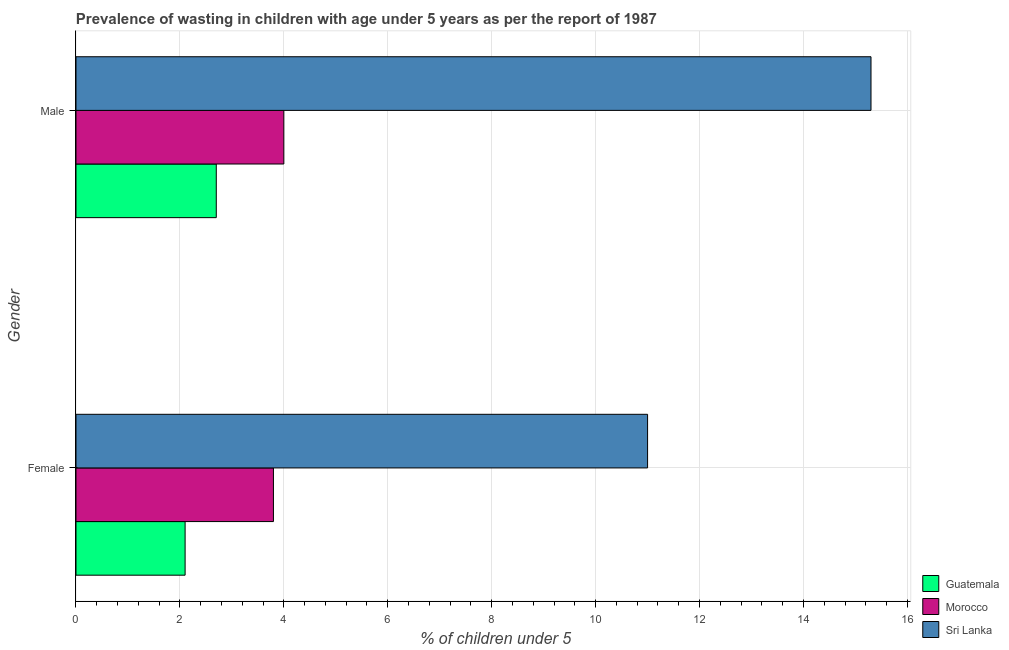How many different coloured bars are there?
Your answer should be compact. 3. What is the label of the 2nd group of bars from the top?
Offer a very short reply. Female. What is the percentage of undernourished female children in Morocco?
Your answer should be very brief. 3.8. Across all countries, what is the maximum percentage of undernourished female children?
Make the answer very short. 11. Across all countries, what is the minimum percentage of undernourished female children?
Offer a very short reply. 2.1. In which country was the percentage of undernourished male children maximum?
Make the answer very short. Sri Lanka. In which country was the percentage of undernourished male children minimum?
Offer a very short reply. Guatemala. What is the total percentage of undernourished female children in the graph?
Offer a very short reply. 16.9. What is the difference between the percentage of undernourished female children in Morocco and that in Guatemala?
Provide a succinct answer. 1.7. What is the difference between the percentage of undernourished male children in Sri Lanka and the percentage of undernourished female children in Morocco?
Your answer should be compact. 11.5. What is the average percentage of undernourished male children per country?
Make the answer very short. 7.33. What is the difference between the percentage of undernourished male children and percentage of undernourished female children in Sri Lanka?
Offer a very short reply. 4.3. What is the ratio of the percentage of undernourished male children in Morocco to that in Sri Lanka?
Provide a short and direct response. 0.26. What does the 1st bar from the top in Female represents?
Make the answer very short. Sri Lanka. What does the 3rd bar from the bottom in Male represents?
Offer a very short reply. Sri Lanka. Are all the bars in the graph horizontal?
Your answer should be compact. Yes. How many countries are there in the graph?
Provide a short and direct response. 3. Does the graph contain any zero values?
Your response must be concise. No. Does the graph contain grids?
Provide a short and direct response. Yes. Where does the legend appear in the graph?
Provide a short and direct response. Bottom right. How are the legend labels stacked?
Make the answer very short. Vertical. What is the title of the graph?
Provide a succinct answer. Prevalence of wasting in children with age under 5 years as per the report of 1987. Does "Australia" appear as one of the legend labels in the graph?
Your answer should be compact. No. What is the label or title of the X-axis?
Provide a succinct answer.  % of children under 5. What is the  % of children under 5 of Guatemala in Female?
Keep it short and to the point. 2.1. What is the  % of children under 5 in Morocco in Female?
Provide a succinct answer. 3.8. What is the  % of children under 5 in Sri Lanka in Female?
Keep it short and to the point. 11. What is the  % of children under 5 in Guatemala in Male?
Provide a succinct answer. 2.7. What is the  % of children under 5 of Sri Lanka in Male?
Your response must be concise. 15.3. Across all Gender, what is the maximum  % of children under 5 of Guatemala?
Ensure brevity in your answer.  2.7. Across all Gender, what is the maximum  % of children under 5 in Morocco?
Your answer should be compact. 4. Across all Gender, what is the maximum  % of children under 5 in Sri Lanka?
Provide a succinct answer. 15.3. Across all Gender, what is the minimum  % of children under 5 in Guatemala?
Your answer should be very brief. 2.1. Across all Gender, what is the minimum  % of children under 5 of Morocco?
Keep it short and to the point. 3.8. What is the total  % of children under 5 of Sri Lanka in the graph?
Provide a succinct answer. 26.3. What is the difference between the  % of children under 5 of Guatemala in Female and that in Male?
Offer a very short reply. -0.6. What is the difference between the  % of children under 5 of Sri Lanka in Female and that in Male?
Make the answer very short. -4.3. What is the difference between the  % of children under 5 in Guatemala in Female and the  % of children under 5 in Sri Lanka in Male?
Ensure brevity in your answer.  -13.2. What is the average  % of children under 5 in Morocco per Gender?
Ensure brevity in your answer.  3.9. What is the average  % of children under 5 of Sri Lanka per Gender?
Offer a terse response. 13.15. What is the difference between the  % of children under 5 of Guatemala and  % of children under 5 of Sri Lanka in Female?
Your answer should be compact. -8.9. What is the difference between the  % of children under 5 in Morocco and  % of children under 5 in Sri Lanka in Female?
Offer a terse response. -7.2. What is the difference between the  % of children under 5 in Guatemala and  % of children under 5 in Sri Lanka in Male?
Provide a short and direct response. -12.6. What is the difference between the  % of children under 5 in Morocco and  % of children under 5 in Sri Lanka in Male?
Your answer should be compact. -11.3. What is the ratio of the  % of children under 5 of Guatemala in Female to that in Male?
Give a very brief answer. 0.78. What is the ratio of the  % of children under 5 in Morocco in Female to that in Male?
Give a very brief answer. 0.95. What is the ratio of the  % of children under 5 of Sri Lanka in Female to that in Male?
Keep it short and to the point. 0.72. 